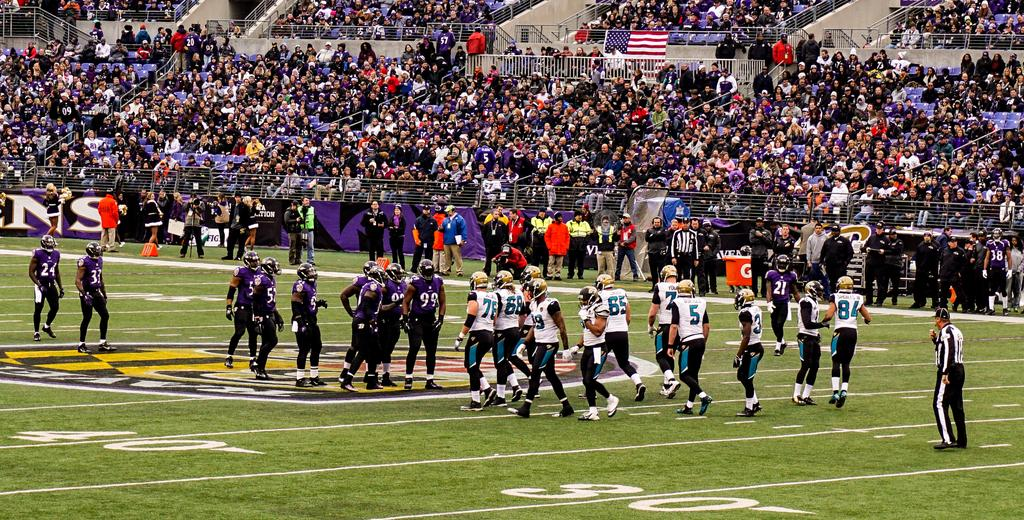What is the main setting of the image? The main setting of the image is a ground. What activities are taking place on the ground? There are players on the ground, suggesting some form of game or sport. What can be seen in the background of the image? In the background, there are people sitting on chairs and people standing. What type of support does the government provide for the players in the image? There is no mention of a government or any form of support in the image; it simply shows players on a ground with people in the background. 